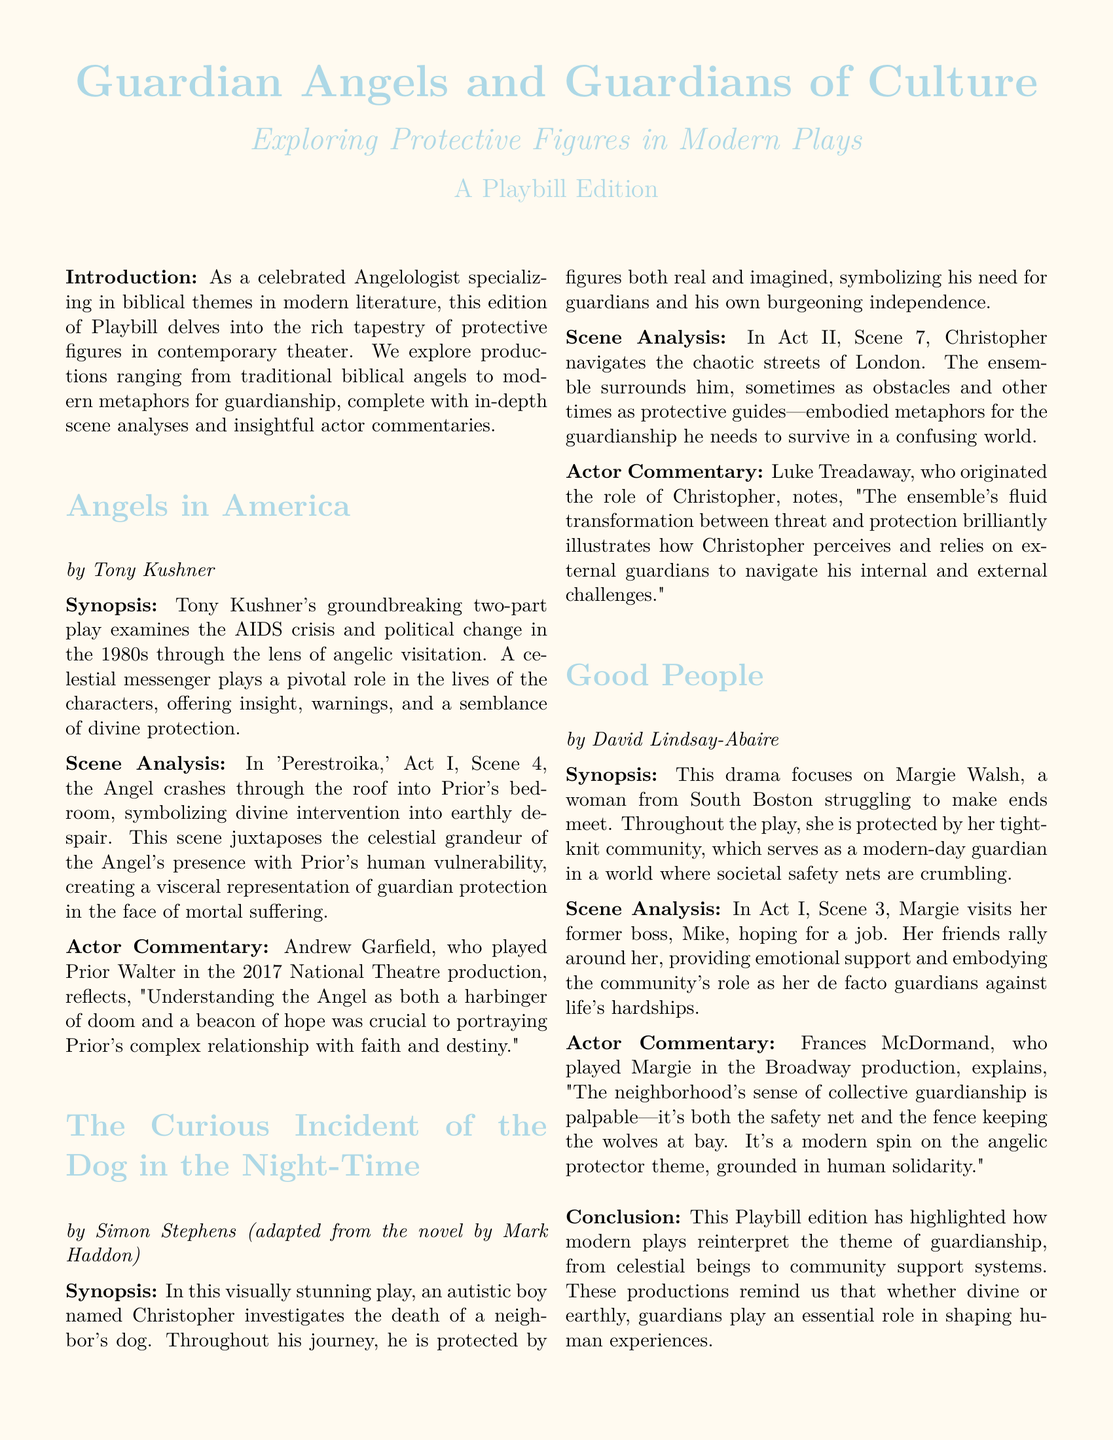What is the title of the play by Tony Kushner? The title of the play is mentioned as "Angels in America" in the document.
Answer: Angels in America Who is the author of "The Curious Incident of the Dog in the Night-Time"? The document states that the play is adapted by Simon Stephens from a novel by Mark Haddon.
Answer: Simon Stephens In which act and scene does the angel crash through the roof? The document specifies that this event occurs in 'Perestroika,' Act I, Scene 4.
Answer: Act I, Scene 4 Who played the role of Margie in the Broadway production of "Good People"? The document names Frances McDormand as the actress who played Margie in the Broadway production.
Answer: Frances McDormand What significant theme does "Good People" explore? The play explores the theme of community as a form of protection for Margie Walsh in her struggles.
Answer: Community How does Prior Walter perceive the angel in "Angels in America"? According to Andrew Garfield, Prior's relationship with the Angel is complex, viewing it as both doom and hope.
Answer: Doom and hope What metaphor is used for guardianship in "The Curious Incident of the Dog in the Night-Time"? The ensemble's fluid transformation between threat and protection symbolizes guardianship in the play.
Answer: Ensemble What does the introduction of the Playbill focus on? The introduction highlights the exploration of protective figures in modern theater, including angels and community guardians.
Answer: Protective figures In what year did the National Theatre produce "Angels in America"? The document mentions the production year as 2017.
Answer: 2017 